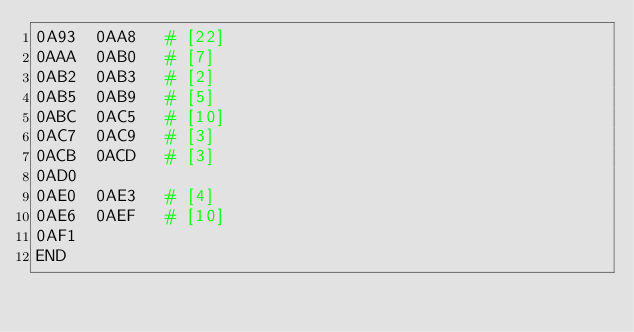<code> <loc_0><loc_0><loc_500><loc_500><_Perl_>0A93	0AA8	 # [22]
0AAA	0AB0	 # [7]
0AB2	0AB3	 # [2]
0AB5	0AB9	 # [5]
0ABC	0AC5	 # [10]
0AC7	0AC9	 # [3]
0ACB	0ACD	 # [3]
0AD0		
0AE0	0AE3	 # [4]
0AE6	0AEF	 # [10]
0AF1		
END
</code> 